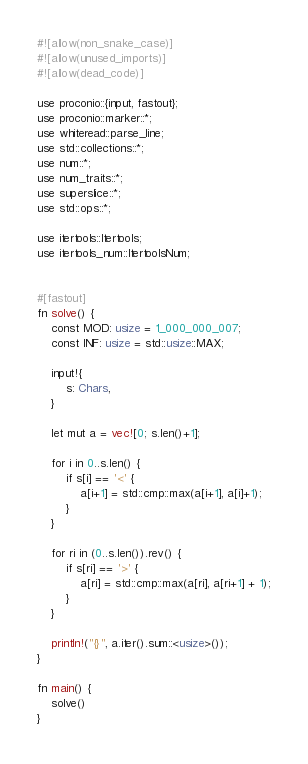Convert code to text. <code><loc_0><loc_0><loc_500><loc_500><_Rust_>#![allow(non_snake_case)]
#![allow(unused_imports)]
#![allow(dead_code)]

use proconio::{input, fastout};
use proconio::marker::*;
use whiteread::parse_line;
use std::collections::*;
use num::*;
use num_traits::*;
use superslice::*;
use std::ops::*;

use itertools::Itertools;
use itertools_num::ItertoolsNum;


#[fastout]
fn solve() {
    const MOD: usize = 1_000_000_007;
    const INF: usize = std::usize::MAX;
    
    input!{
        s: Chars,
    }

    let mut a = vec![0; s.len()+1];

    for i in 0..s.len() {
        if s[i] == '<' {
            a[i+1] = std::cmp::max(a[i+1], a[i]+1);
        }
    }

    for ri in (0..s.len()).rev() {
        if s[ri] == '>' {
            a[ri] = std::cmp::max(a[ri], a[ri+1] + 1);
        }
    }

    println!("{}", a.iter().sum::<usize>());
}

fn main() {
    solve()
}
</code> 